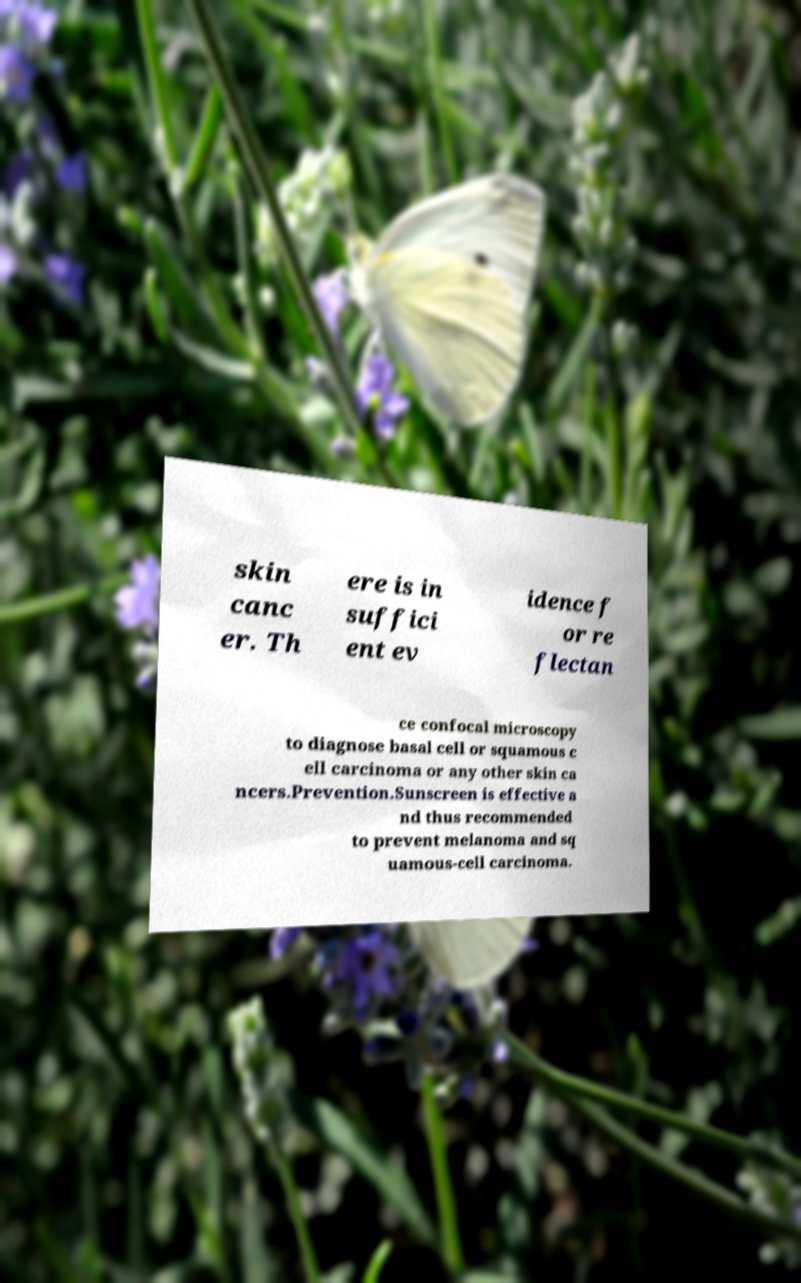I need the written content from this picture converted into text. Can you do that? skin canc er. Th ere is in suffici ent ev idence f or re flectan ce confocal microscopy to diagnose basal cell or squamous c ell carcinoma or any other skin ca ncers.Prevention.Sunscreen is effective a nd thus recommended to prevent melanoma and sq uamous-cell carcinoma. 